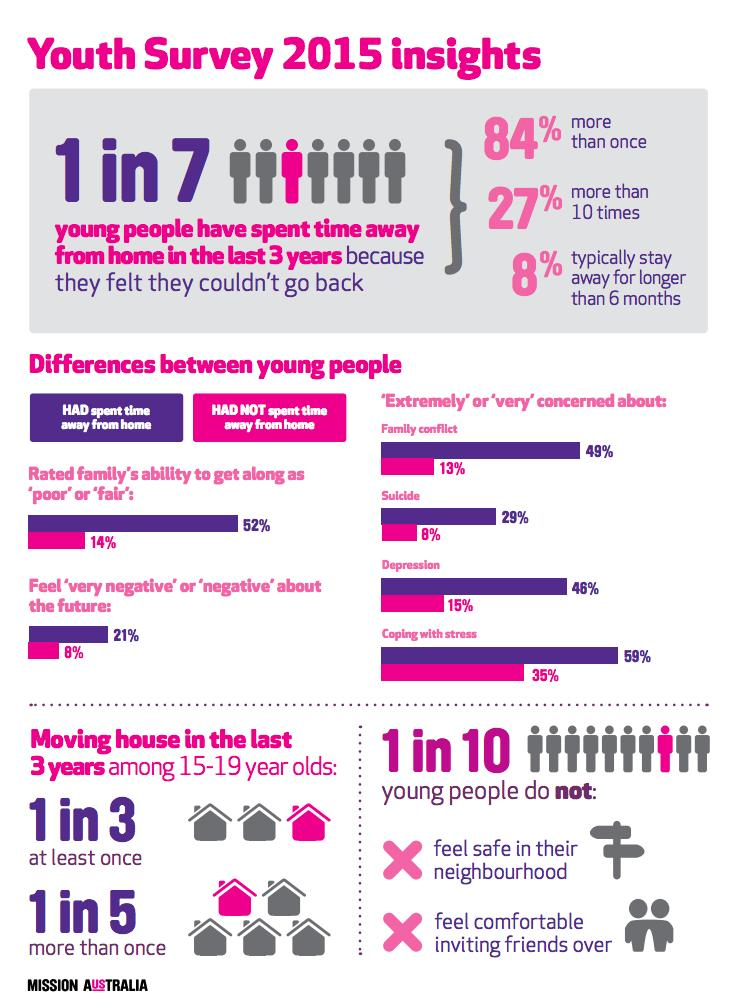Outline some significant characteristics in this image. The youth who had spent time away from home are more likely to feel negative about their future compared to the youth who had not spent time away from home. According to a recent survey, 10% of young people do not feel safe in their neighborhoods. It is more likely for youth who have spent time away from home to be concerned about depression compared to those who have not spent time away from home. It is more likely for youth who have spent time away from home to be concerned about suicide compared to those who have not spent time away from home. It is more likely for youth who had spent time away from home to be concerned about family conflict compared to those who had not spent time away from home. 